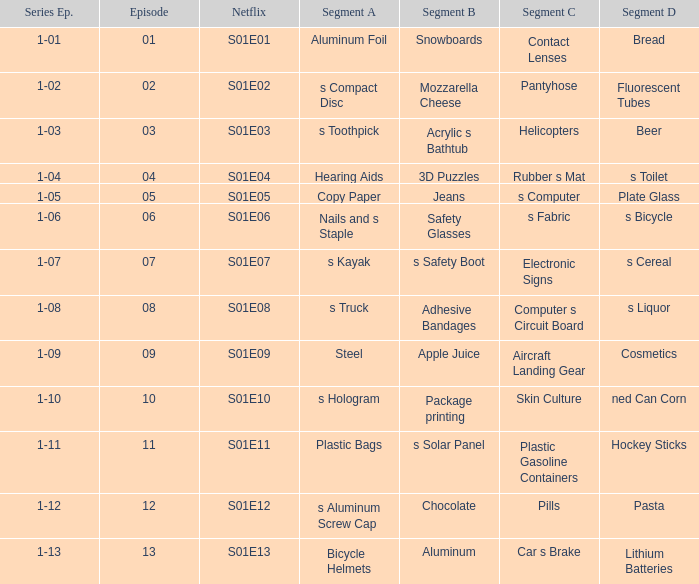In which netflix segment can we find a section containing c pills? S01E12. 